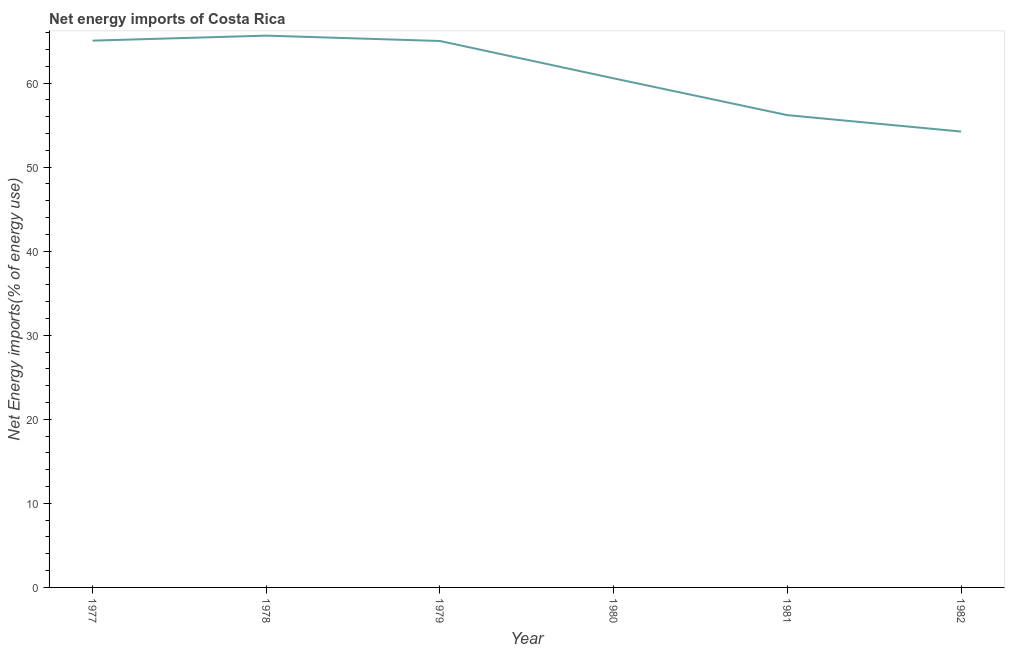What is the energy imports in 1977?
Make the answer very short. 65.05. Across all years, what is the maximum energy imports?
Offer a very short reply. 65.64. Across all years, what is the minimum energy imports?
Give a very brief answer. 54.23. In which year was the energy imports maximum?
Provide a succinct answer. 1978. In which year was the energy imports minimum?
Offer a very short reply. 1982. What is the sum of the energy imports?
Offer a very short reply. 366.67. What is the difference between the energy imports in 1977 and 1979?
Keep it short and to the point. 0.04. What is the average energy imports per year?
Offer a very short reply. 61.11. What is the median energy imports?
Provide a succinct answer. 62.78. In how many years, is the energy imports greater than 50 %?
Provide a succinct answer. 6. Do a majority of the years between 1981 and 1978 (inclusive) have energy imports greater than 64 %?
Ensure brevity in your answer.  Yes. What is the ratio of the energy imports in 1979 to that in 1980?
Give a very brief answer. 1.07. What is the difference between the highest and the second highest energy imports?
Offer a terse response. 0.6. Is the sum of the energy imports in 1978 and 1982 greater than the maximum energy imports across all years?
Your response must be concise. Yes. What is the difference between the highest and the lowest energy imports?
Give a very brief answer. 11.41. How many years are there in the graph?
Your response must be concise. 6. What is the difference between two consecutive major ticks on the Y-axis?
Provide a short and direct response. 10. Does the graph contain any zero values?
Make the answer very short. No. What is the title of the graph?
Your answer should be compact. Net energy imports of Costa Rica. What is the label or title of the X-axis?
Your answer should be compact. Year. What is the label or title of the Y-axis?
Provide a short and direct response. Net Energy imports(% of energy use). What is the Net Energy imports(% of energy use) in 1977?
Provide a succinct answer. 65.05. What is the Net Energy imports(% of energy use) in 1978?
Provide a short and direct response. 65.64. What is the Net Energy imports(% of energy use) of 1979?
Keep it short and to the point. 65. What is the Net Energy imports(% of energy use) in 1980?
Provide a short and direct response. 60.56. What is the Net Energy imports(% of energy use) in 1981?
Make the answer very short. 56.18. What is the Net Energy imports(% of energy use) of 1982?
Your answer should be compact. 54.23. What is the difference between the Net Energy imports(% of energy use) in 1977 and 1978?
Make the answer very short. -0.6. What is the difference between the Net Energy imports(% of energy use) in 1977 and 1979?
Offer a terse response. 0.04. What is the difference between the Net Energy imports(% of energy use) in 1977 and 1980?
Provide a succinct answer. 4.49. What is the difference between the Net Energy imports(% of energy use) in 1977 and 1981?
Make the answer very short. 8.86. What is the difference between the Net Energy imports(% of energy use) in 1977 and 1982?
Give a very brief answer. 10.82. What is the difference between the Net Energy imports(% of energy use) in 1978 and 1979?
Offer a very short reply. 0.64. What is the difference between the Net Energy imports(% of energy use) in 1978 and 1980?
Provide a succinct answer. 5.08. What is the difference between the Net Energy imports(% of energy use) in 1978 and 1981?
Give a very brief answer. 9.46. What is the difference between the Net Energy imports(% of energy use) in 1978 and 1982?
Your answer should be compact. 11.41. What is the difference between the Net Energy imports(% of energy use) in 1979 and 1980?
Give a very brief answer. 4.44. What is the difference between the Net Energy imports(% of energy use) in 1979 and 1981?
Offer a very short reply. 8.82. What is the difference between the Net Energy imports(% of energy use) in 1979 and 1982?
Your answer should be very brief. 10.77. What is the difference between the Net Energy imports(% of energy use) in 1980 and 1981?
Offer a terse response. 4.38. What is the difference between the Net Energy imports(% of energy use) in 1980 and 1982?
Give a very brief answer. 6.33. What is the difference between the Net Energy imports(% of energy use) in 1981 and 1982?
Your answer should be compact. 1.95. What is the ratio of the Net Energy imports(% of energy use) in 1977 to that in 1980?
Make the answer very short. 1.07. What is the ratio of the Net Energy imports(% of energy use) in 1977 to that in 1981?
Provide a short and direct response. 1.16. What is the ratio of the Net Energy imports(% of energy use) in 1977 to that in 1982?
Offer a very short reply. 1.2. What is the ratio of the Net Energy imports(% of energy use) in 1978 to that in 1980?
Your answer should be very brief. 1.08. What is the ratio of the Net Energy imports(% of energy use) in 1978 to that in 1981?
Offer a very short reply. 1.17. What is the ratio of the Net Energy imports(% of energy use) in 1978 to that in 1982?
Offer a very short reply. 1.21. What is the ratio of the Net Energy imports(% of energy use) in 1979 to that in 1980?
Provide a succinct answer. 1.07. What is the ratio of the Net Energy imports(% of energy use) in 1979 to that in 1981?
Offer a very short reply. 1.16. What is the ratio of the Net Energy imports(% of energy use) in 1979 to that in 1982?
Provide a succinct answer. 1.2. What is the ratio of the Net Energy imports(% of energy use) in 1980 to that in 1981?
Keep it short and to the point. 1.08. What is the ratio of the Net Energy imports(% of energy use) in 1980 to that in 1982?
Offer a very short reply. 1.12. What is the ratio of the Net Energy imports(% of energy use) in 1981 to that in 1982?
Offer a very short reply. 1.04. 